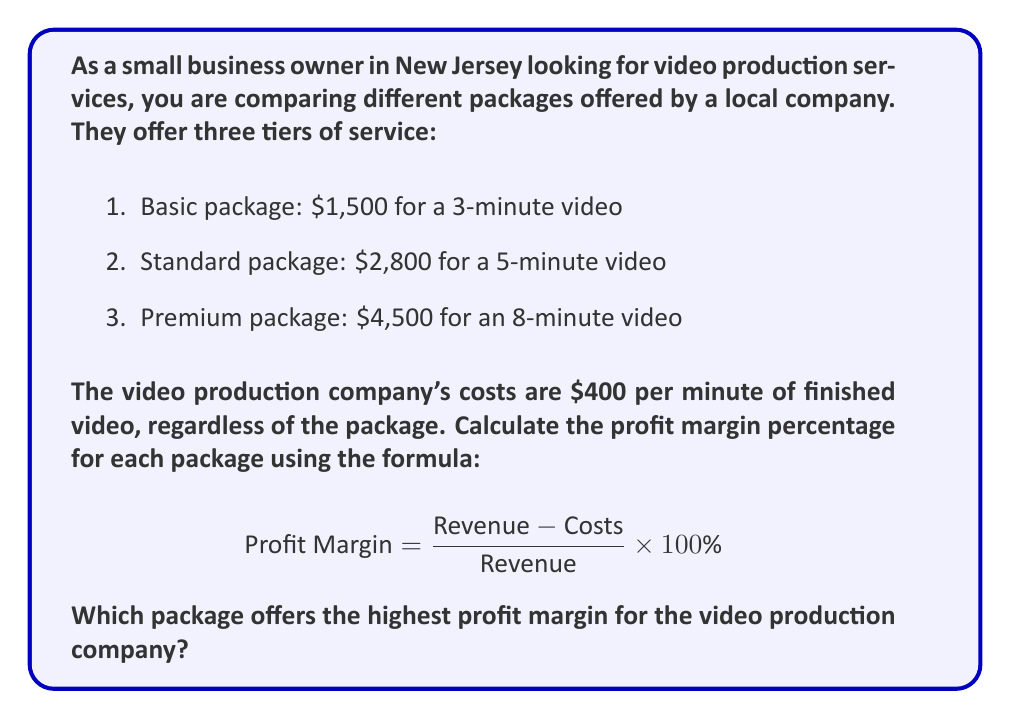Provide a solution to this math problem. Let's calculate the profit margin for each package:

1. Basic package:
   Revenue: $1,500
   Costs: $400 × 3 minutes = $1,200
   
   $$ \text{Profit Margin}_{\text{Basic}} = \frac{1500 - 1200}{1500} \times 100\% = \frac{300}{1500} \times 100\% = 20\% $$

2. Standard package:
   Revenue: $2,800
   Costs: $400 × 5 minutes = $2,000
   
   $$ \text{Profit Margin}_{\text{Standard}} = \frac{2800 - 2000}{2800} \times 100\% = \frac{800}{2800} \times 100\% \approx 28.57\% $$

3. Premium package:
   Revenue: $4,500
   Costs: $400 × 8 minutes = $3,200
   
   $$ \text{Profit Margin}_{\text{Premium}} = \frac{4500 - 3200}{4500} \times 100\% = \frac{1300}{4500} \times 100\% \approx 28.89\% $$

Comparing the profit margins:
Basic: 20%
Standard: 28.57%
Premium: 28.89%

The Premium package offers the highest profit margin for the video production company.
Answer: The Premium package offers the highest profit margin at approximately 28.89%. 